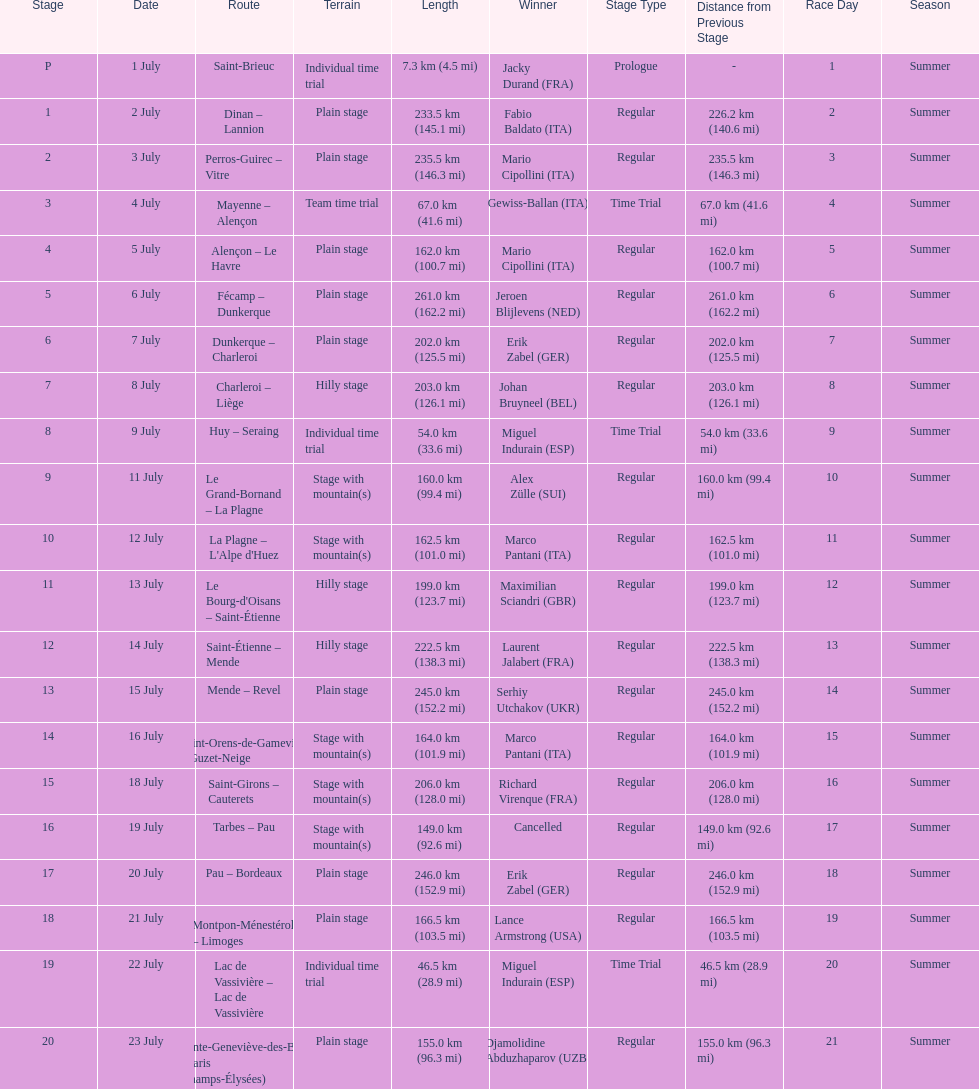Which routes were at least 100 km? Dinan - Lannion, Perros-Guirec - Vitre, Alençon - Le Havre, Fécamp - Dunkerque, Dunkerque - Charleroi, Charleroi - Liège, Le Grand-Bornand - La Plagne, La Plagne - L'Alpe d'Huez, Le Bourg-d'Oisans - Saint-Étienne, Saint-Étienne - Mende, Mende - Revel, Saint-Orens-de-Gameville - Guzet-Neige, Saint-Girons - Cauterets, Tarbes - Pau, Pau - Bordeaux, Montpon-Ménestérol - Limoges, Sainte-Geneviève-des-Bois - Paris (Champs-Élysées). 